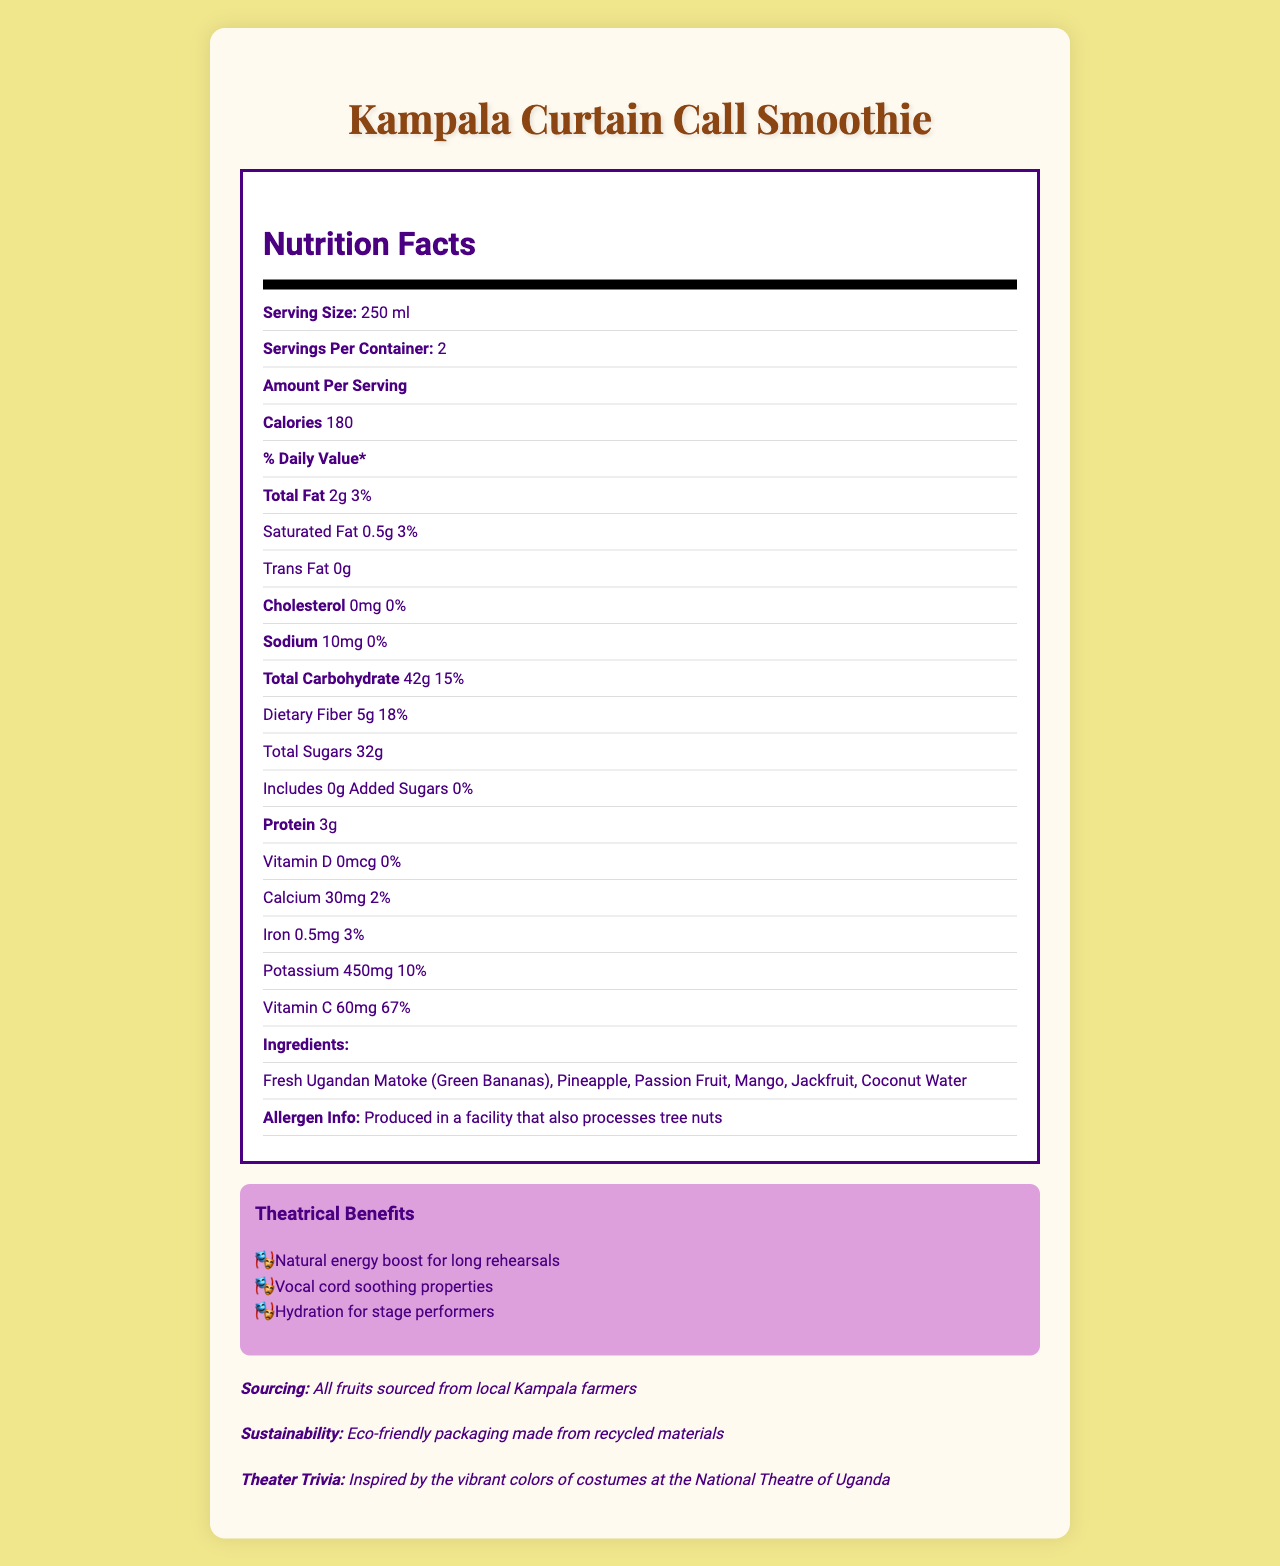what is the serving size? The serving size is listed at the top of the nutrition facts section.
Answer: 250 ml how many servings are there per container? The servings per container are listed right below the serving size.
Answer: 2 how many calories are in one serving of the smoothie? The amount of calories per serving is stated under the "Amount Per Serving" section.
Answer: 180 how much total fat is in each serving? The total fat per serving is listed in the "Total Fat" row.
Answer: 2g what is the daily value percentage of vitamin C per serving? The daily value percentage for vitamin C is mentioned under the vitamins section.
Answer: 67% choose the ingredient not listed in the smoothie: A. Fresh Ugandan Matoke B. Pineapple C. Orange D. Jackfruit Orange is not listed among the ingredients; the listed ingredients include Fresh Ugandan Matoke, Pineapple, Passion Fruit, Mango, Jackfruit, and Coconut Water.
Answer: C how much potassium does each serving contain? A. 450mg B. 30mg C. 180mg D. 10mg The potassium content per serving is 450mg as stated in the document.
Answer: A is there any cholesterol in the smoothie? The cholesterol content is listed as 0mg with a daily value percentage of 0%.
Answer: No summarize the main idea of the document The summary should cover the inclusion of nutritional content, ingredients, theatrical benefits, sourcing, and the sustainability aspects of the smoothie in question.
Answer: The document provides detailed nutritional information and ingredient list for the "Kampala Curtain Call Smoothie," a locally-sourced fruit drink. It highlights various nutritional components, theatrical benefits, and sustainability features. what percentage of the daily value of dietary fiber is present per serving? The percentage daily value for dietary fiber is noted as 18% in the nutrition facts section.
Answer: 18% what is the origin of the fruits used in the smoothie? The sourcing section mentions that all fruits are sourced from local farmers in Kampala.
Answer: All fruits are sourced from local Kampala farmers are there any added sugars in the smoothie? The document specifies that there are 0g of added sugars in the smoothie.
Answer: No what is the sustainability feature mentioned in the document? The sustainability section states that the packaging is eco-friendly and made from recycled materials.
Answer: Eco-friendly packaging made from recycled materials what type of allergens may be present in the facility that processes the smoothie? The allergen information mentions that the facility also processes tree nuts.
Answer: Tree nuts how many grams of protein does each serving contain? The protein content per serving is listed as 3g in the nutrition facts section.
Answer: 3g how does the smoothie benefit theater performers? The theatrical benefits section lists natural energy boost, vocal cord soothing properties, and hydration for stage performers as benefits.
Answer: Natural energy boost, vocal cord soothing, hydration what inspired the smoothie? The theater trivia section states that the smoothie is inspired by the vibrant colors of costumes at the National Theatre of Uganda.
Answer: Vibrant colors of costumes at the National Theatre of Uganda how many servings are in the entire container? The document states there are 2 servings per container.
Answer: 2 how much calcium does each serving contain? The document lists the calcium content as 30mg per serving.
Answer: 30mg how much sodium is in one serving? The sodium content per serving is stated as 10mg.
Answer: 10mg how many grams of saturated fat are in each serving? The saturated fat content per serving is listed as 0.5g.
Answer: 0.5g what is the total carbohydrate amount per serving? The total carbohydrate content per serving is provided as 42g.
Answer: 42g who are the intended primary consumers of this smoothie? The document highlights that the smoothie is popular among Kampala's theater performers and includes theatrical benefits targeted towards them.
Answer: Theater performers 